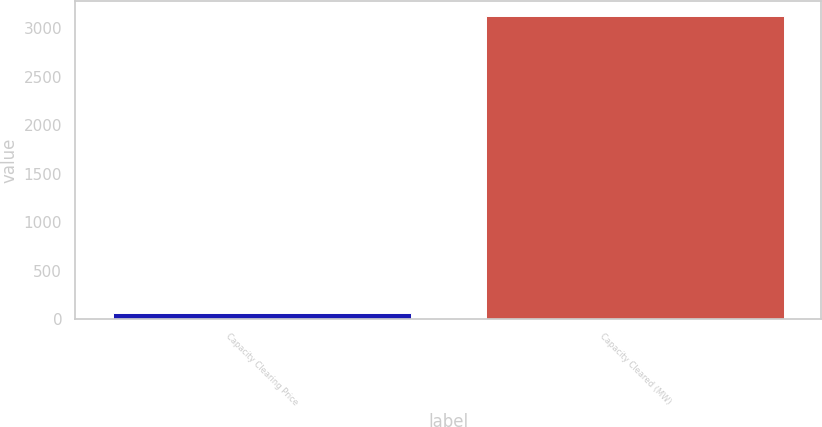Convert chart. <chart><loc_0><loc_0><loc_500><loc_500><bar_chart><fcel>Capacity Clearing Price<fcel>Capacity Cleared (MW)<nl><fcel>59<fcel>3125<nl></chart> 